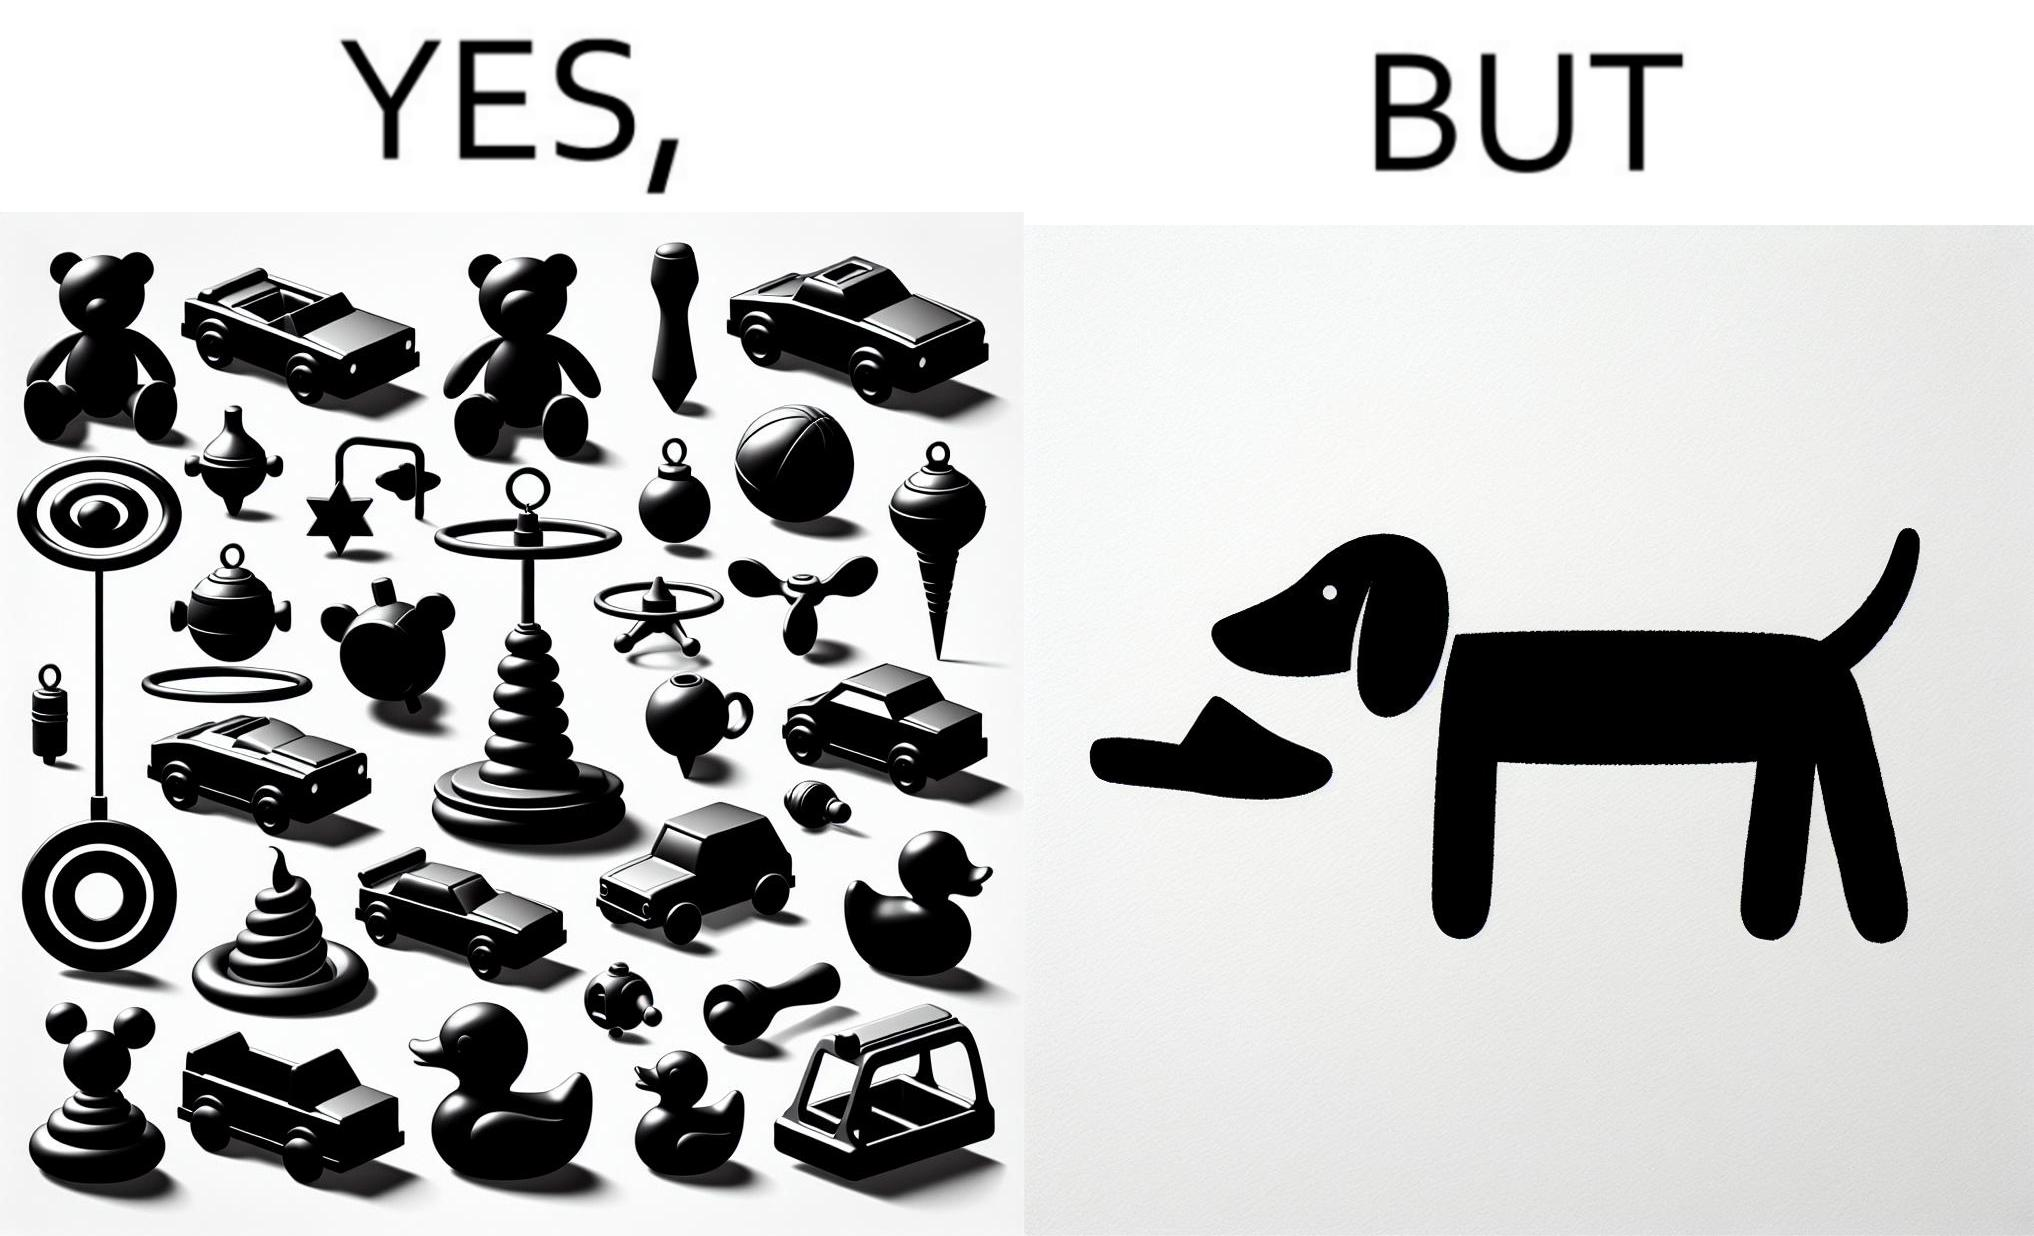Is this a satirical image? Yes, this image is satirical. 